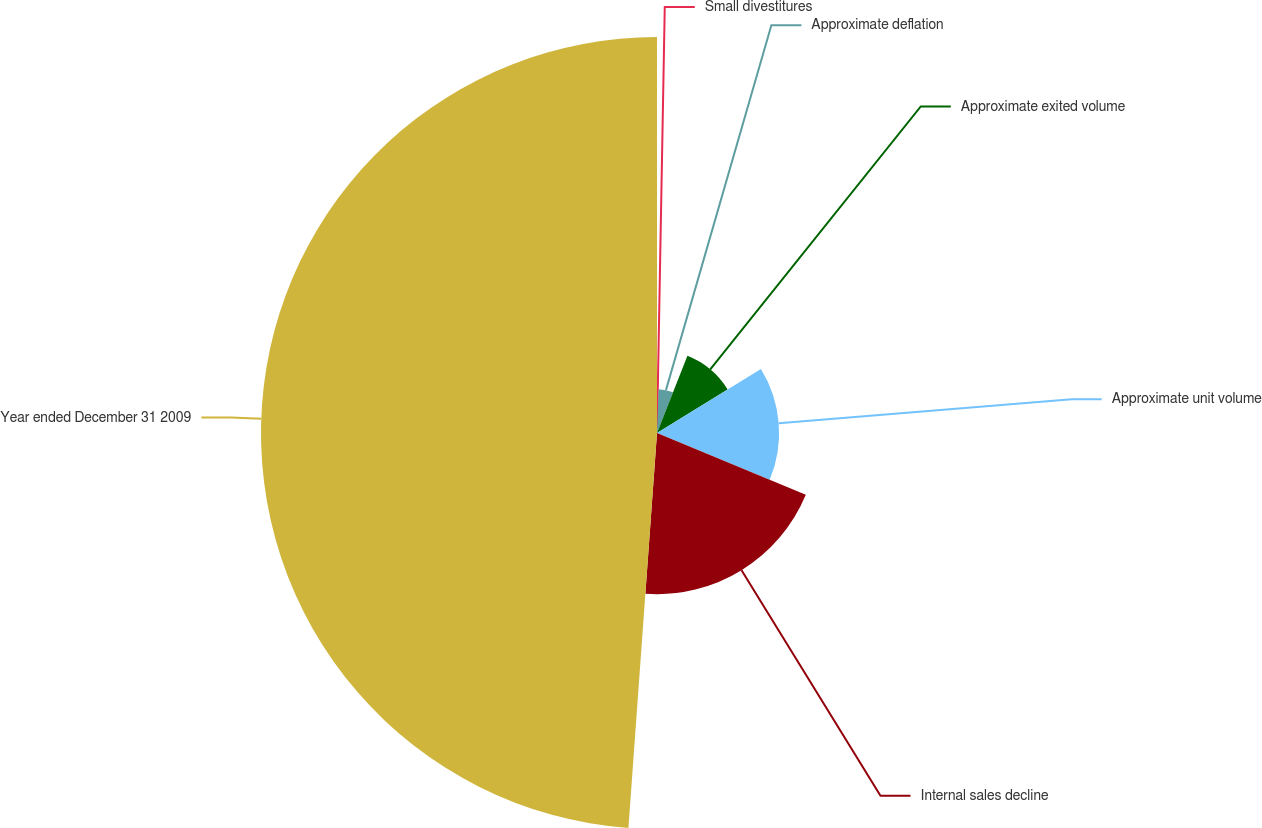<chart> <loc_0><loc_0><loc_500><loc_500><pie_chart><fcel>Small divestitures<fcel>Approximate deflation<fcel>Approximate exited volume<fcel>Approximate unit volume<fcel>Internal sales decline<fcel>Year ended December 31 2009<nl><fcel>0.58%<fcel>5.4%<fcel>10.23%<fcel>15.06%<fcel>19.88%<fcel>48.85%<nl></chart> 